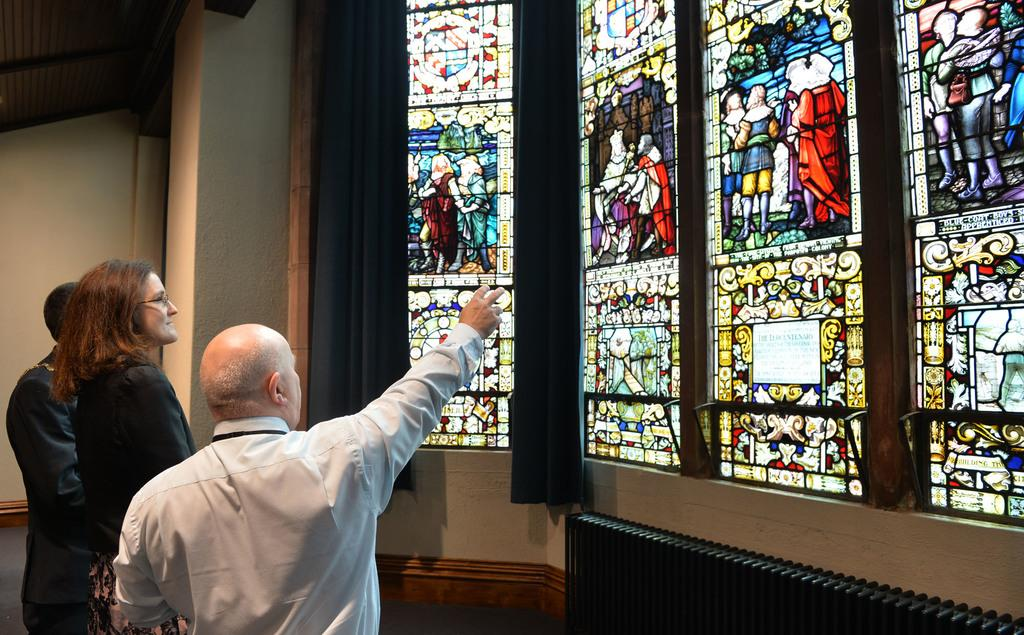How many people are in the image? There are three persons in the image. What can be seen hanging or covering a window in the image? There are curtains in the image. What objects are present that can be used for drinking? There are glasses in the image. What type of structure is visible in the background of the image? There is a wall in the image. What type of nut is being cracked by the person in the image? There is no nut present in the image, and no one is cracking a nut. 